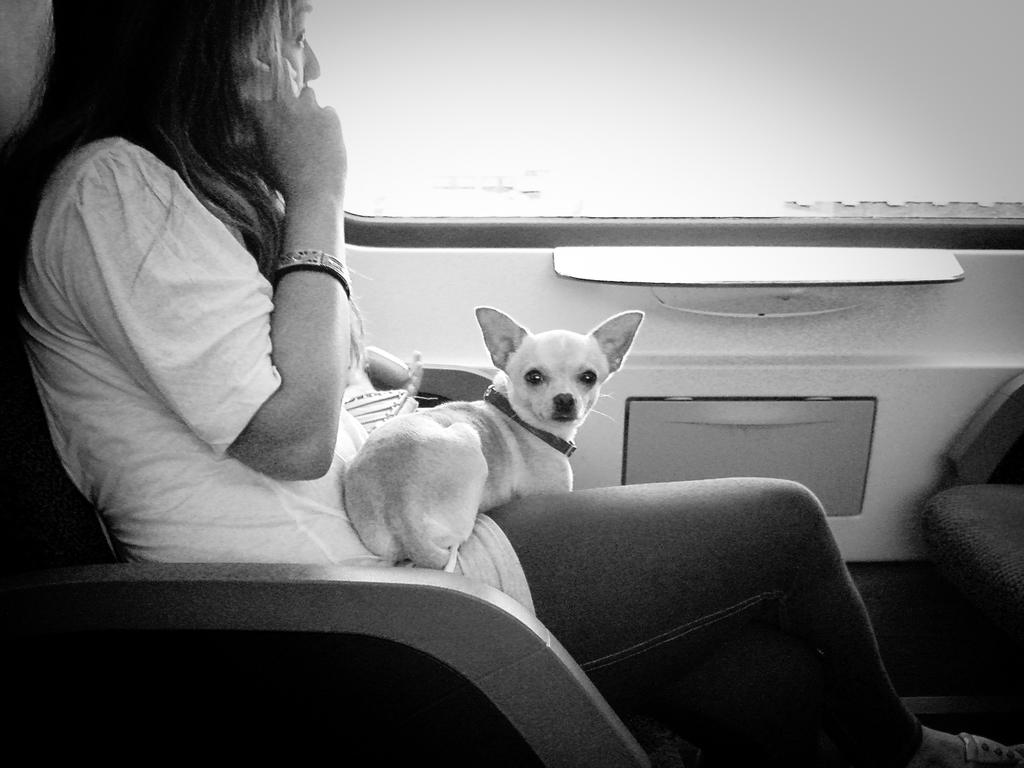What is the color scheme of the image? The image is black and white. Who is present in the image? There is a woman in the image. What is the woman doing in the image? The woman is sitting on the seat of a motor vehicle. Is there any other living creature in the image besides the woman? Yes, there is a dog in the image. How is the dog positioned in relation to the woman? The dog is on the woman's lap. Where is the nearest playground to the location depicted in the image? The image does not provide any information about the location or the presence of a playground. --- 